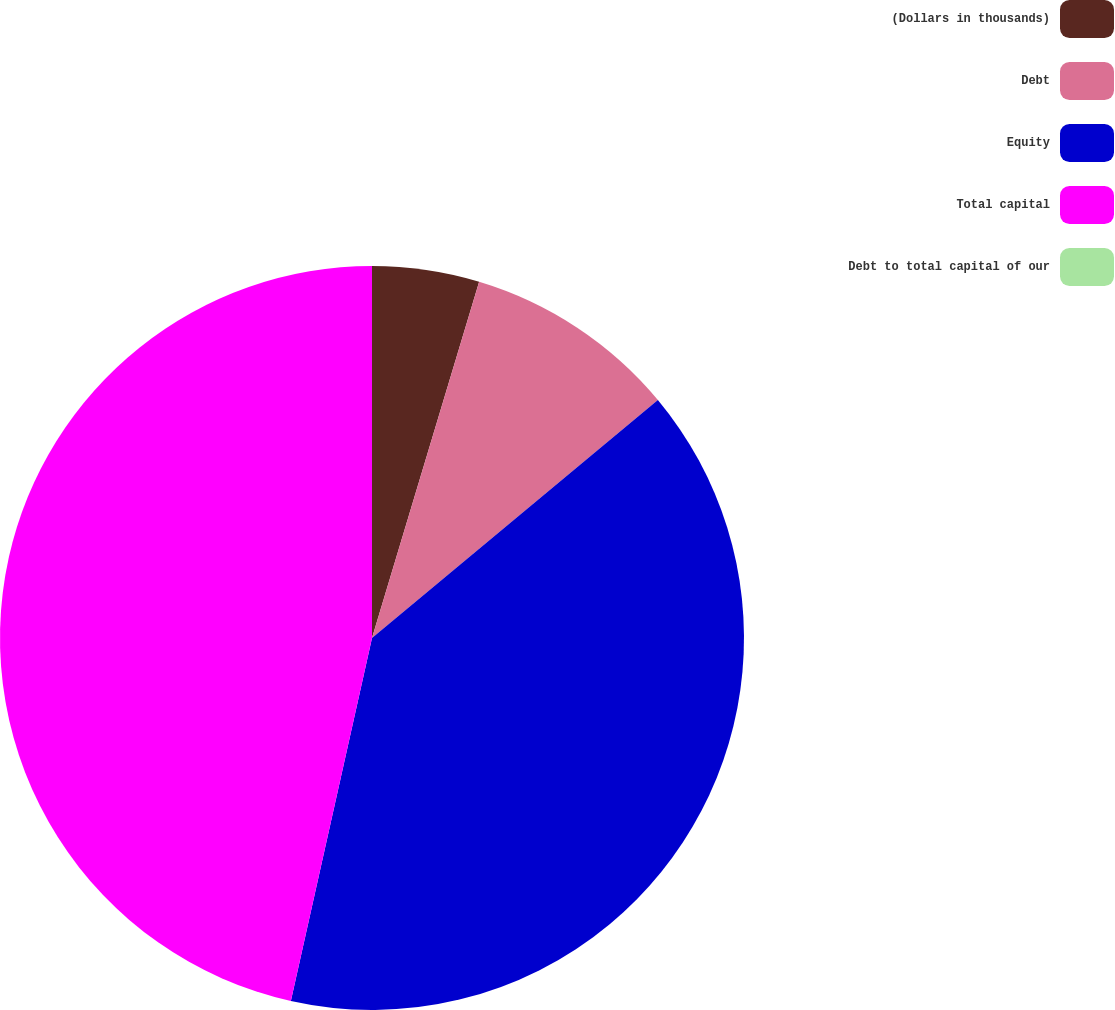<chart> <loc_0><loc_0><loc_500><loc_500><pie_chart><fcel>(Dollars in thousands)<fcel>Debt<fcel>Equity<fcel>Total capital<fcel>Debt to total capital of our<nl><fcel>4.65%<fcel>9.3%<fcel>39.55%<fcel>46.5%<fcel>0.0%<nl></chart> 